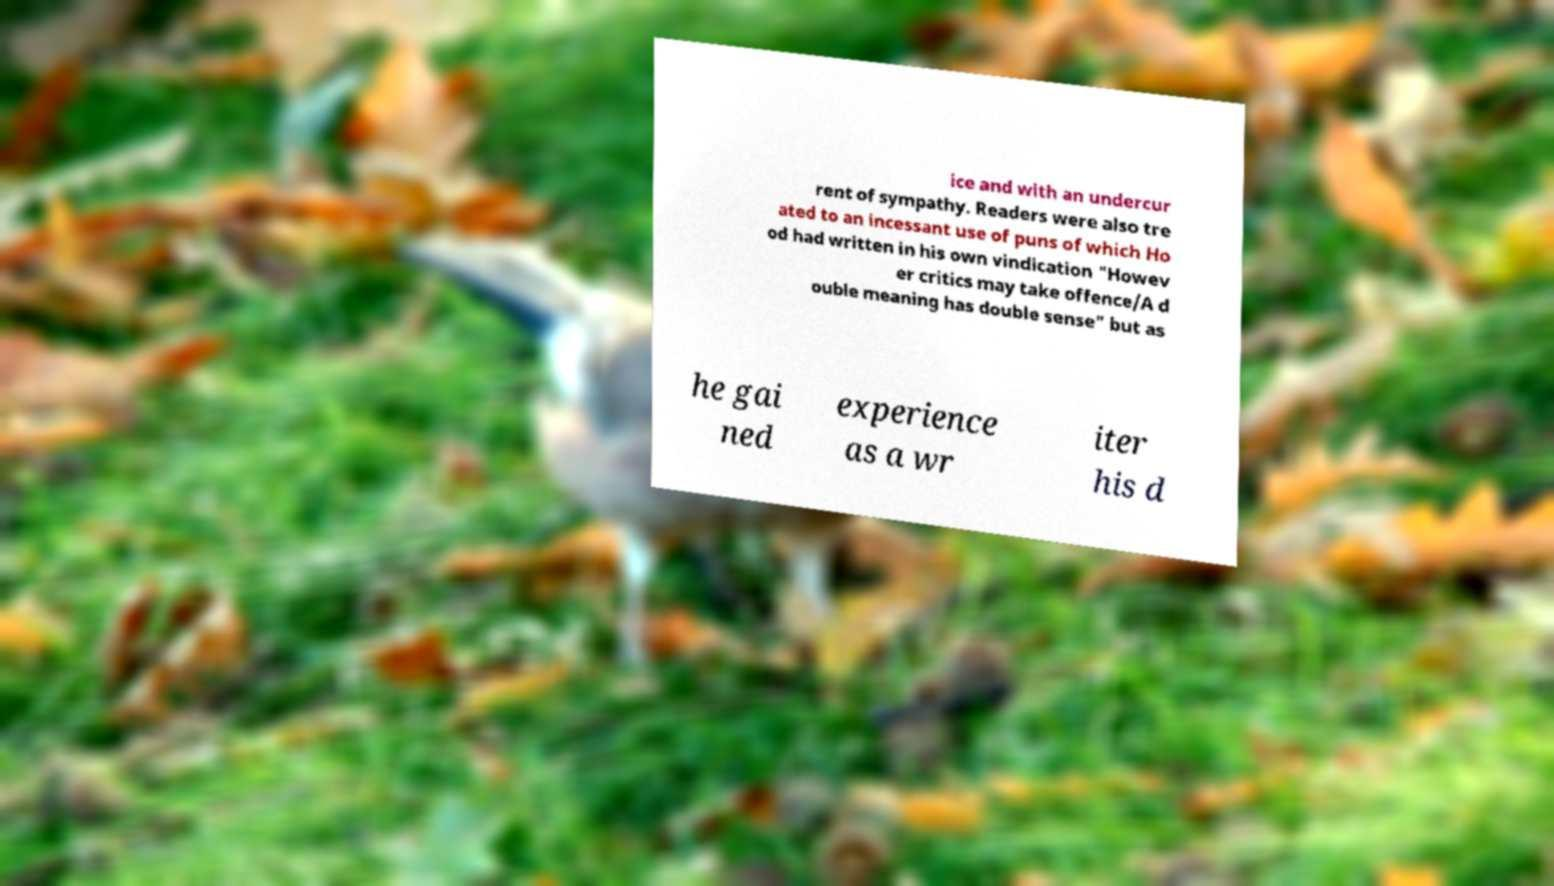Could you extract and type out the text from this image? ice and with an undercur rent of sympathy. Readers were also tre ated to an incessant use of puns of which Ho od had written in his own vindication "Howev er critics may take offence/A d ouble meaning has double sense" but as he gai ned experience as a wr iter his d 